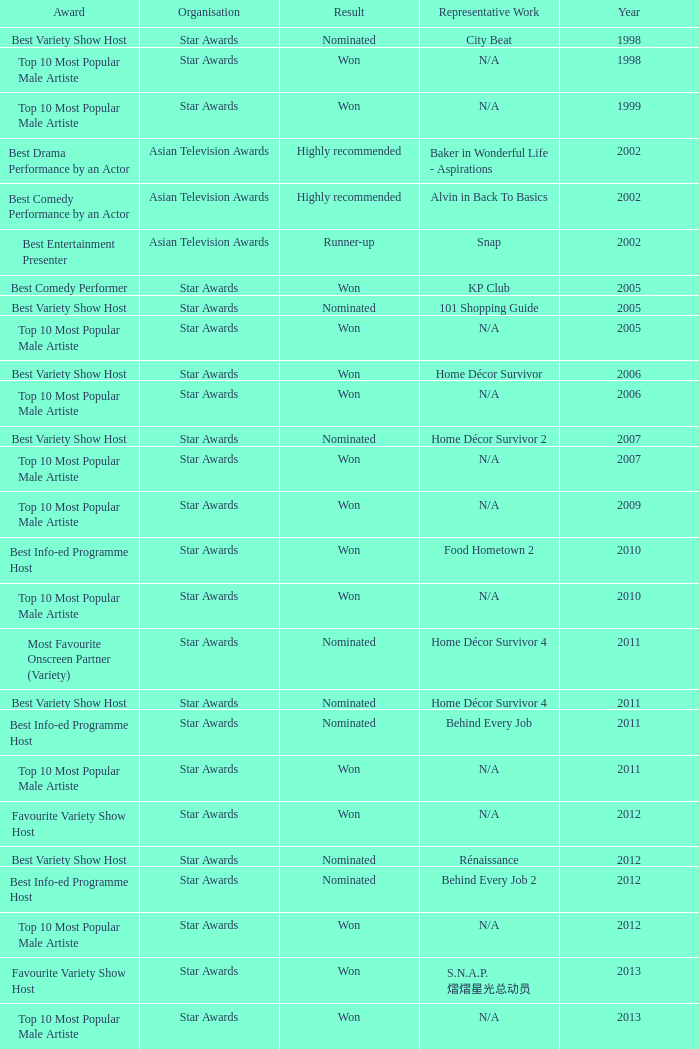What is the organisation in 2011 that was nominated and the award of best info-ed programme host? Star Awards. 